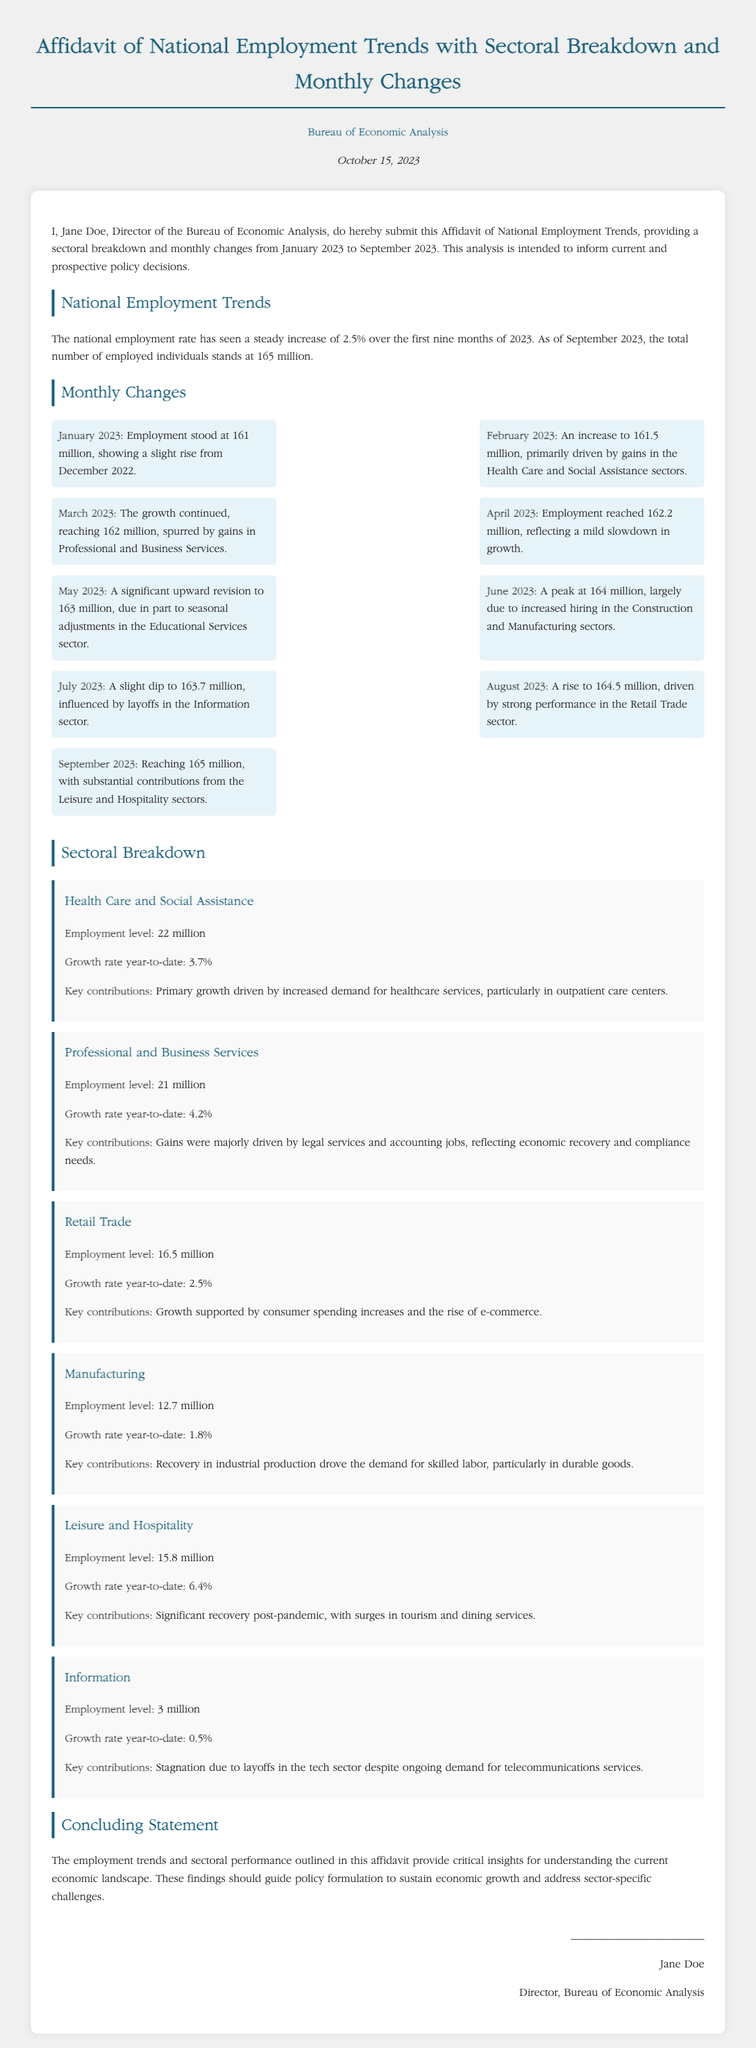What is the total employment number as of September 2023? The total employment number is mentioned in the document as 165 million as of September 2023.
Answer: 165 million What sector had the highest growth rate year-to-date? The sector with the highest growth rate year-to-date is Leisure and Hospitality with a growth rate of 6.4%.
Answer: 6.4% Who is the Director of the Bureau of Economic Analysis? The document states that Jane Doe is the Director of the Bureau of Economic Analysis.
Answer: Jane Doe What was the employment level in March 2023? The employment level in March 2023 is reported as 162 million.
Answer: 162 million What main factor contributed to the growth in the Health Care and Social Assistance sector? The primary growth was driven by increased demand for healthcare services specifically in outpatient care centers.
Answer: Increased demand for healthcare services What was the employment number in July 2023? The employment number for July 2023 is listed as 163.7 million.
Answer: 163.7 million What is the total employment change from January to September 2023? The total employment change from January to September is 4 million, calculated from 161 million in January to 165 million in September.
Answer: 4 million What type of document is this? This is an Affidavit regarding National Employment Trends.
Answer: Affidavit What was the employment level in the Information sector? The employment level in the Information sector is reported as 3 million.
Answer: 3 million 